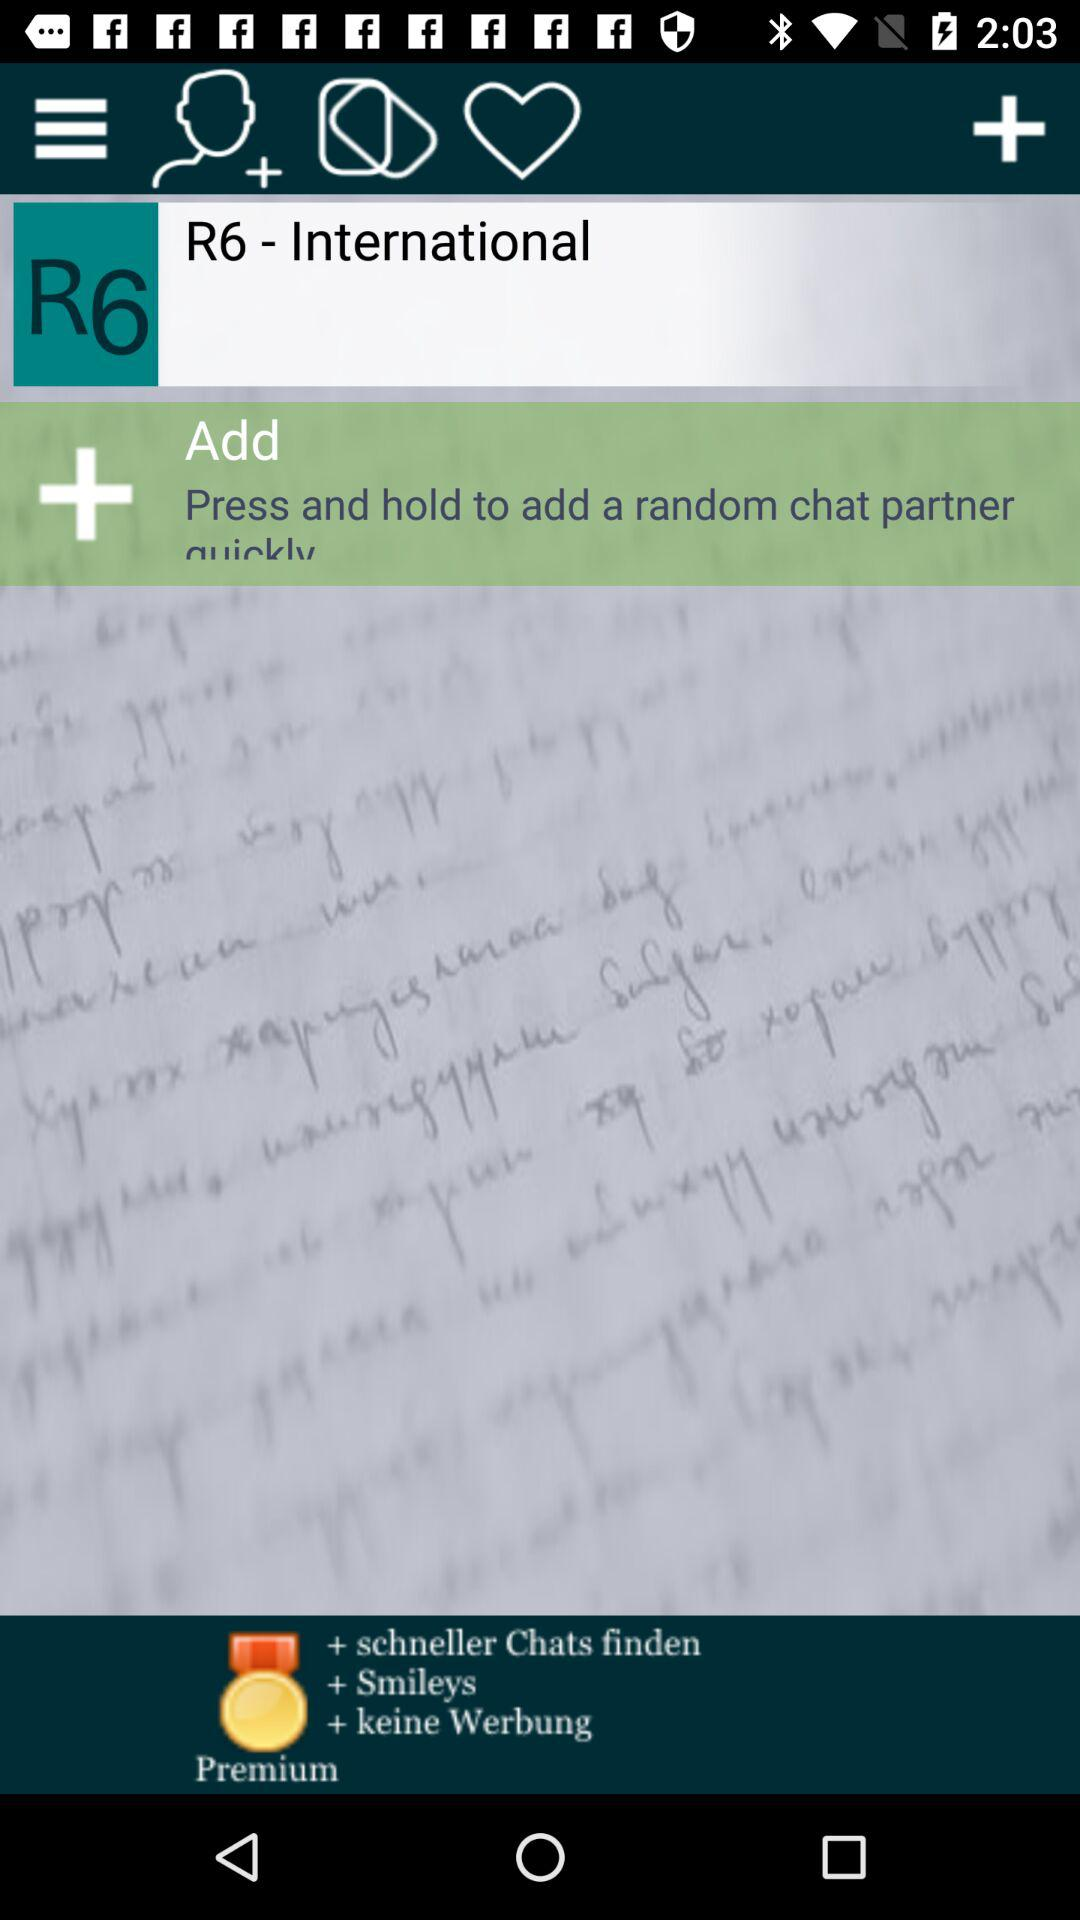What do we need to do to add a chat partner quickly? You need to press and hold to quickly add a chat partner. 